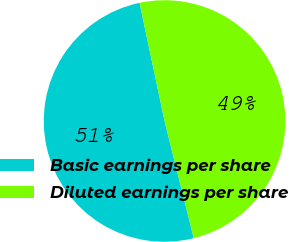Convert chart to OTSL. <chart><loc_0><loc_0><loc_500><loc_500><pie_chart><fcel>Basic earnings per share<fcel>Diluted earnings per share<nl><fcel>50.57%<fcel>49.43%<nl></chart> 